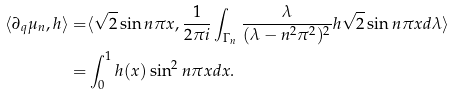<formula> <loc_0><loc_0><loc_500><loc_500>\langle \partial _ { q } \mu _ { n } , h \rangle = & \langle \sqrt { 2 } \sin n \pi x , \frac { 1 } { 2 \pi i } \int _ { \Gamma _ { n } } \frac { \lambda } { ( \lambda - n ^ { 2 } \pi ^ { 2 } ) ^ { 2 } } h \sqrt { 2 } \sin n \pi x d \lambda \rangle \\ = & \int _ { 0 } ^ { 1 } h ( x ) \sin ^ { 2 } n \pi x d x .</formula> 